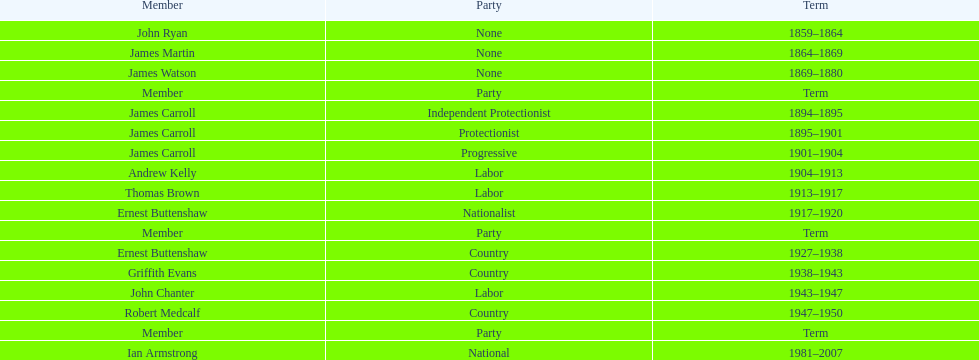For how long did the fourth form of the lachlan persist? 1981-2007. 